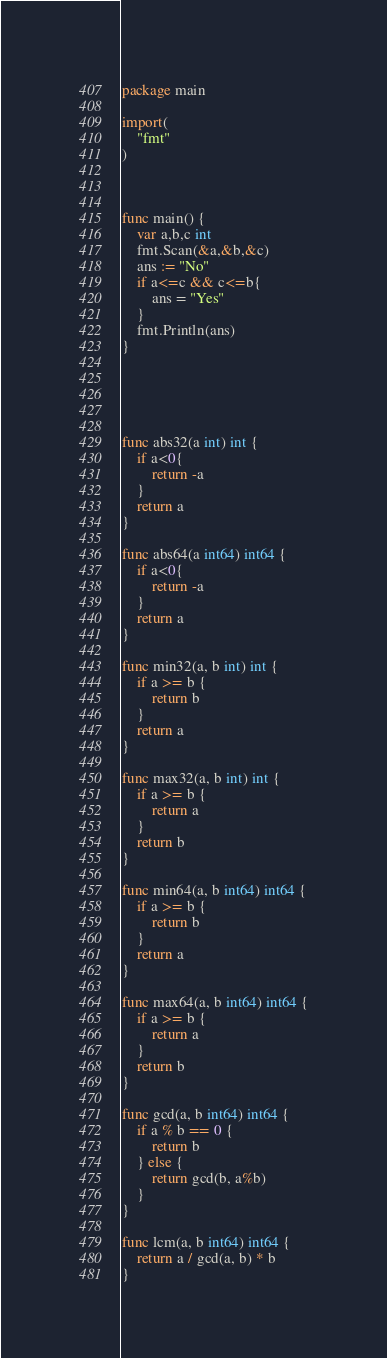Convert code to text. <code><loc_0><loc_0><loc_500><loc_500><_Go_>package main

import(
    "fmt"
)



func main() {
    var a,b,c int
    fmt.Scan(&a,&b,&c)
    ans := "No"
    if a<=c && c<=b{
        ans = "Yes"
    }
    fmt.Println(ans)
}





func abs32(a int) int {
    if a<0{
        return -a
    }
    return a
}

func abs64(a int64) int64 {
    if a<0{
        return -a
    }
    return a
}

func min32(a, b int) int {
    if a >= b {
        return b
    }
    return a
}

func max32(a, b int) int {
    if a >= b {
        return a
    }
    return b
}

func min64(a, b int64) int64 {
    if a >= b {
        return b
    }
    return a
}

func max64(a, b int64) int64 {
    if a >= b {
        return a
    }
    return b
}

func gcd(a, b int64) int64 {
    if a % b == 0 {
        return b
    } else {
        return gcd(b, a%b)
    }
}

func lcm(a, b int64) int64 {
    return a / gcd(a, b) * b
}
</code> 